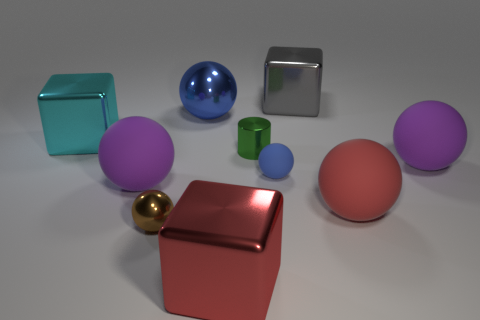Subtract all brown spheres. Subtract all cyan blocks. How many spheres are left? 5 Subtract all purple cylinders. How many gray cubes are left? 1 Add 8 large blues. How many browns exist? 0 Subtract all tiny yellow cylinders. Subtract all big red shiny things. How many objects are left? 9 Add 9 cyan shiny cubes. How many cyan shiny cubes are left? 10 Add 8 blue rubber things. How many blue rubber things exist? 9 Subtract all gray blocks. How many blocks are left? 2 Subtract all small balls. How many balls are left? 4 Subtract 1 red spheres. How many objects are left? 9 How many blue balls must be subtracted to get 1 blue balls? 1 